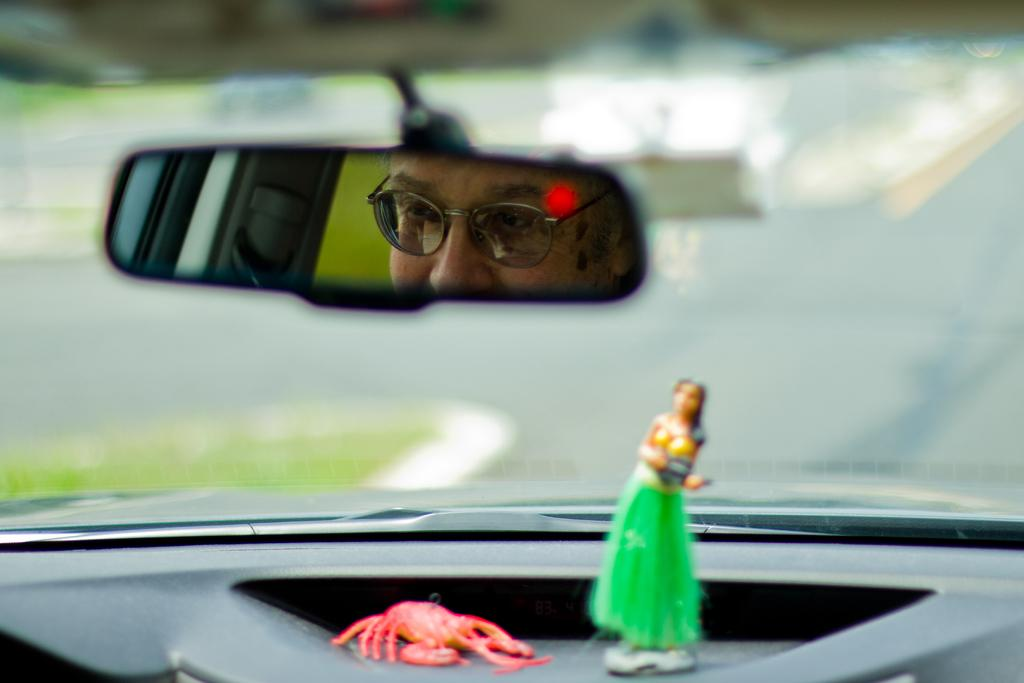What object in the image reflects an image? There is a mirror in the image that reflects an image. What can be seen in the mirror? A human face is visible in the mirror. What type of structure is present in the image? There is a door in the image. How many drawers are visible in the image? There are no drawers present in the image. What statement does the mirror make about the person in the image? The mirror does not make any statements; it simply reflects an image of the person. 